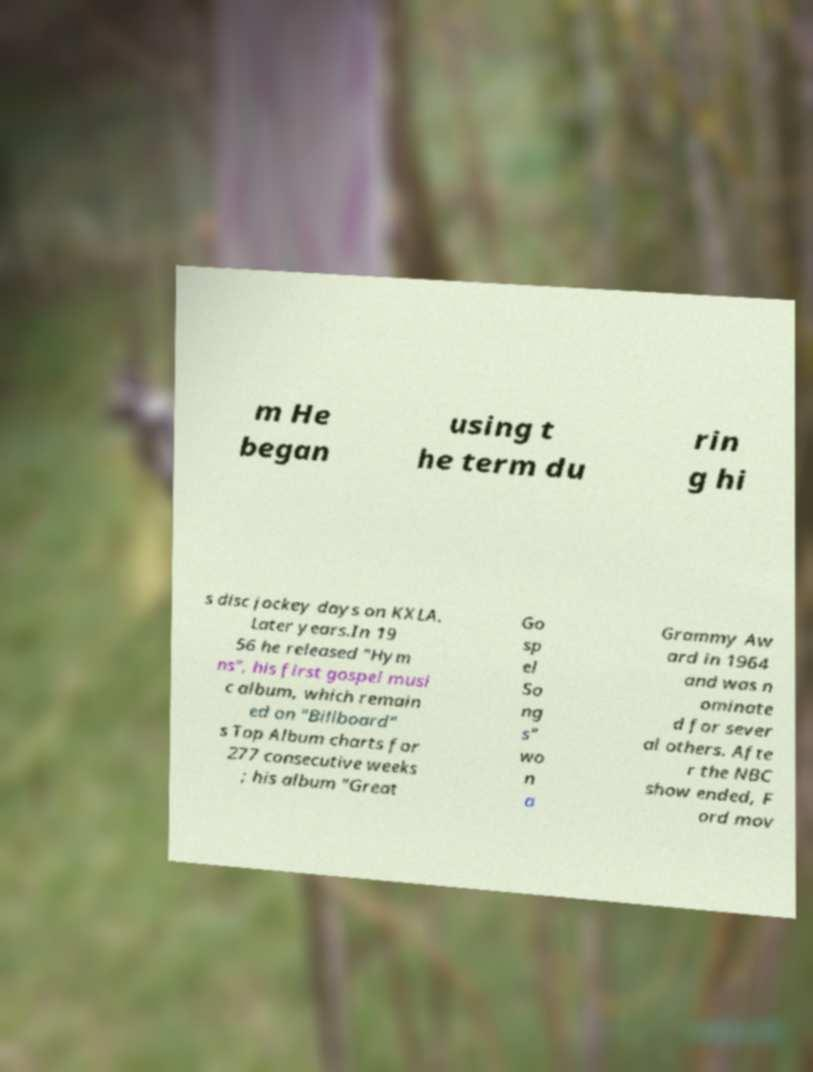Please read and relay the text visible in this image. What does it say? m He began using t he term du rin g hi s disc jockey days on KXLA. Later years.In 19 56 he released "Hym ns", his first gospel musi c album, which remain ed on "Billboard" s Top Album charts for 277 consecutive weeks ; his album "Great Go sp el So ng s" wo n a Grammy Aw ard in 1964 and was n ominate d for sever al others. Afte r the NBC show ended, F ord mov 